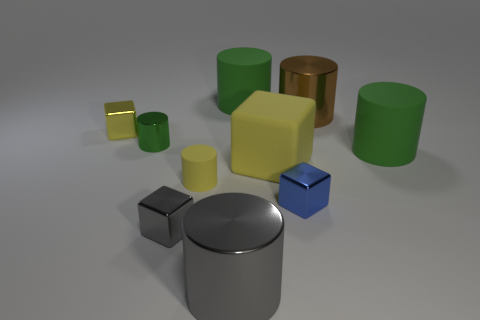How many green cylinders must be subtracted to get 1 green cylinders? 2 Subtract all brown metallic cylinders. How many cylinders are left? 5 Subtract 5 cylinders. How many cylinders are left? 1 Subtract all cylinders. How many objects are left? 4 Add 7 large red metallic spheres. How many large red metallic spheres exist? 7 Subtract all gray cubes. How many cubes are left? 3 Subtract 0 yellow spheres. How many objects are left? 10 Subtract all gray cylinders. Subtract all brown spheres. How many cylinders are left? 5 Subtract all blue spheres. How many brown cylinders are left? 1 Subtract all green matte cylinders. Subtract all brown metal cylinders. How many objects are left? 7 